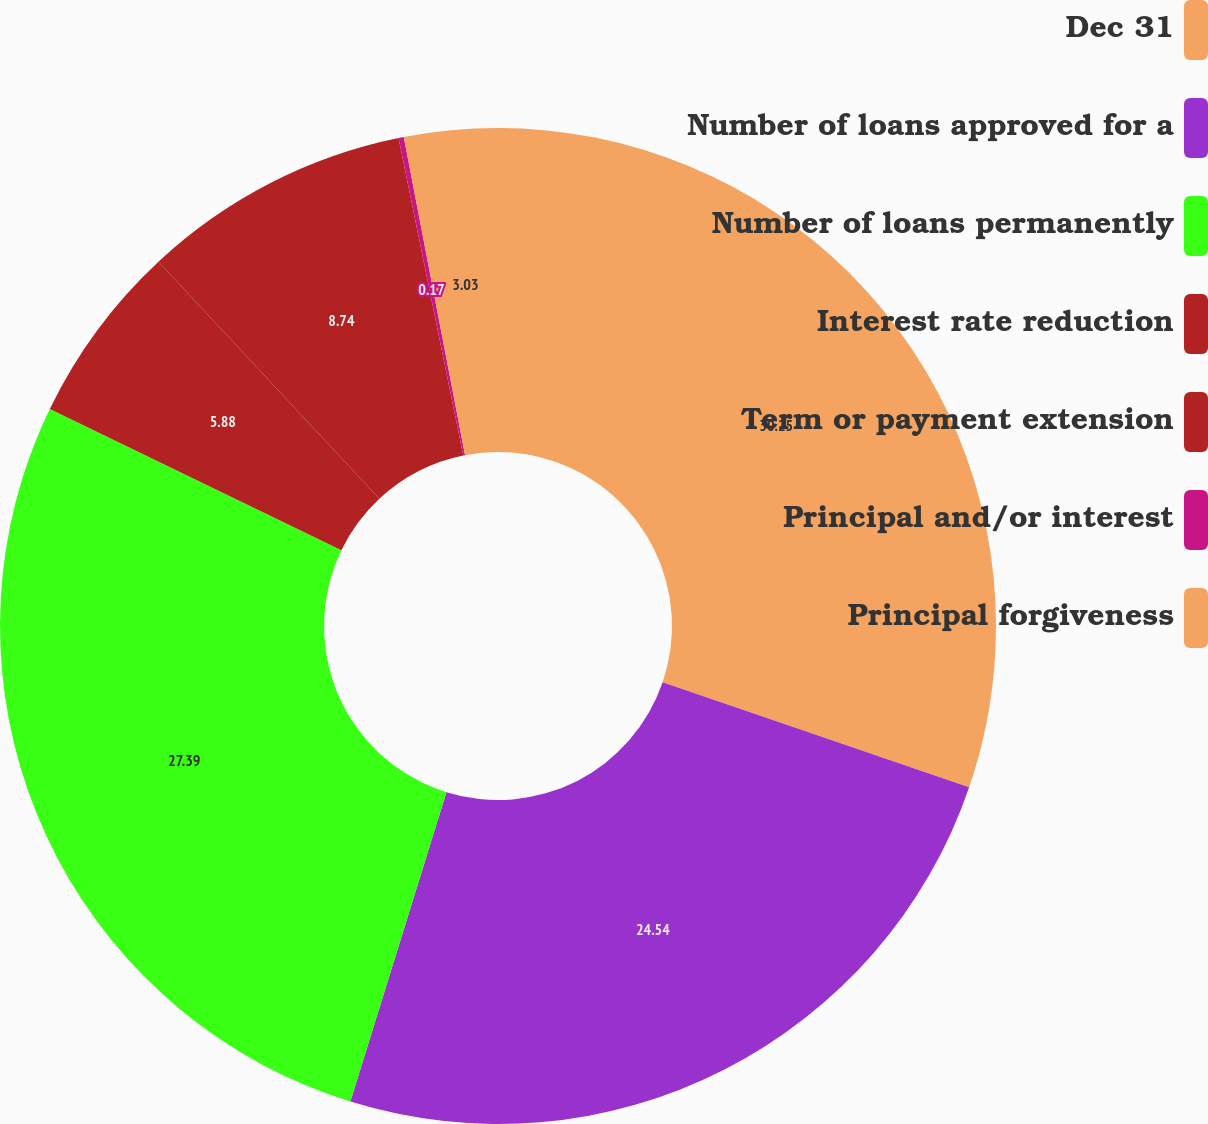Convert chart. <chart><loc_0><loc_0><loc_500><loc_500><pie_chart><fcel>Dec 31<fcel>Number of loans approved for a<fcel>Number of loans permanently<fcel>Interest rate reduction<fcel>Term or payment extension<fcel>Principal and/or interest<fcel>Principal forgiveness<nl><fcel>30.25%<fcel>24.54%<fcel>27.39%<fcel>5.88%<fcel>8.74%<fcel>0.17%<fcel>3.03%<nl></chart> 